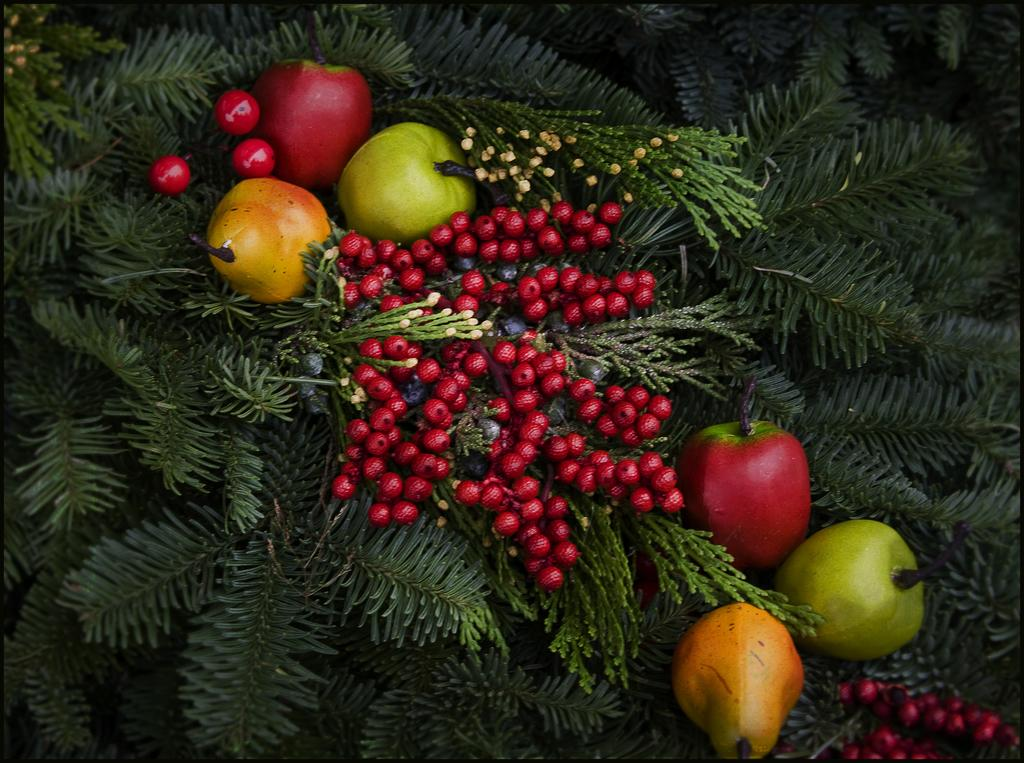What types of fruits are present in the image? There are cherries, guavas, apples, and pears in the image. Can you describe the tree in the background of the image? There is a tree in the background of the image, and it might be a Christmas tree. How is the tree decorated? The tree is decorated with fruits. What type of bike can be seen in the image? There is no bike present in the image. What religious symbolism can be observed in the image? There is no religious symbolism present in the image. 